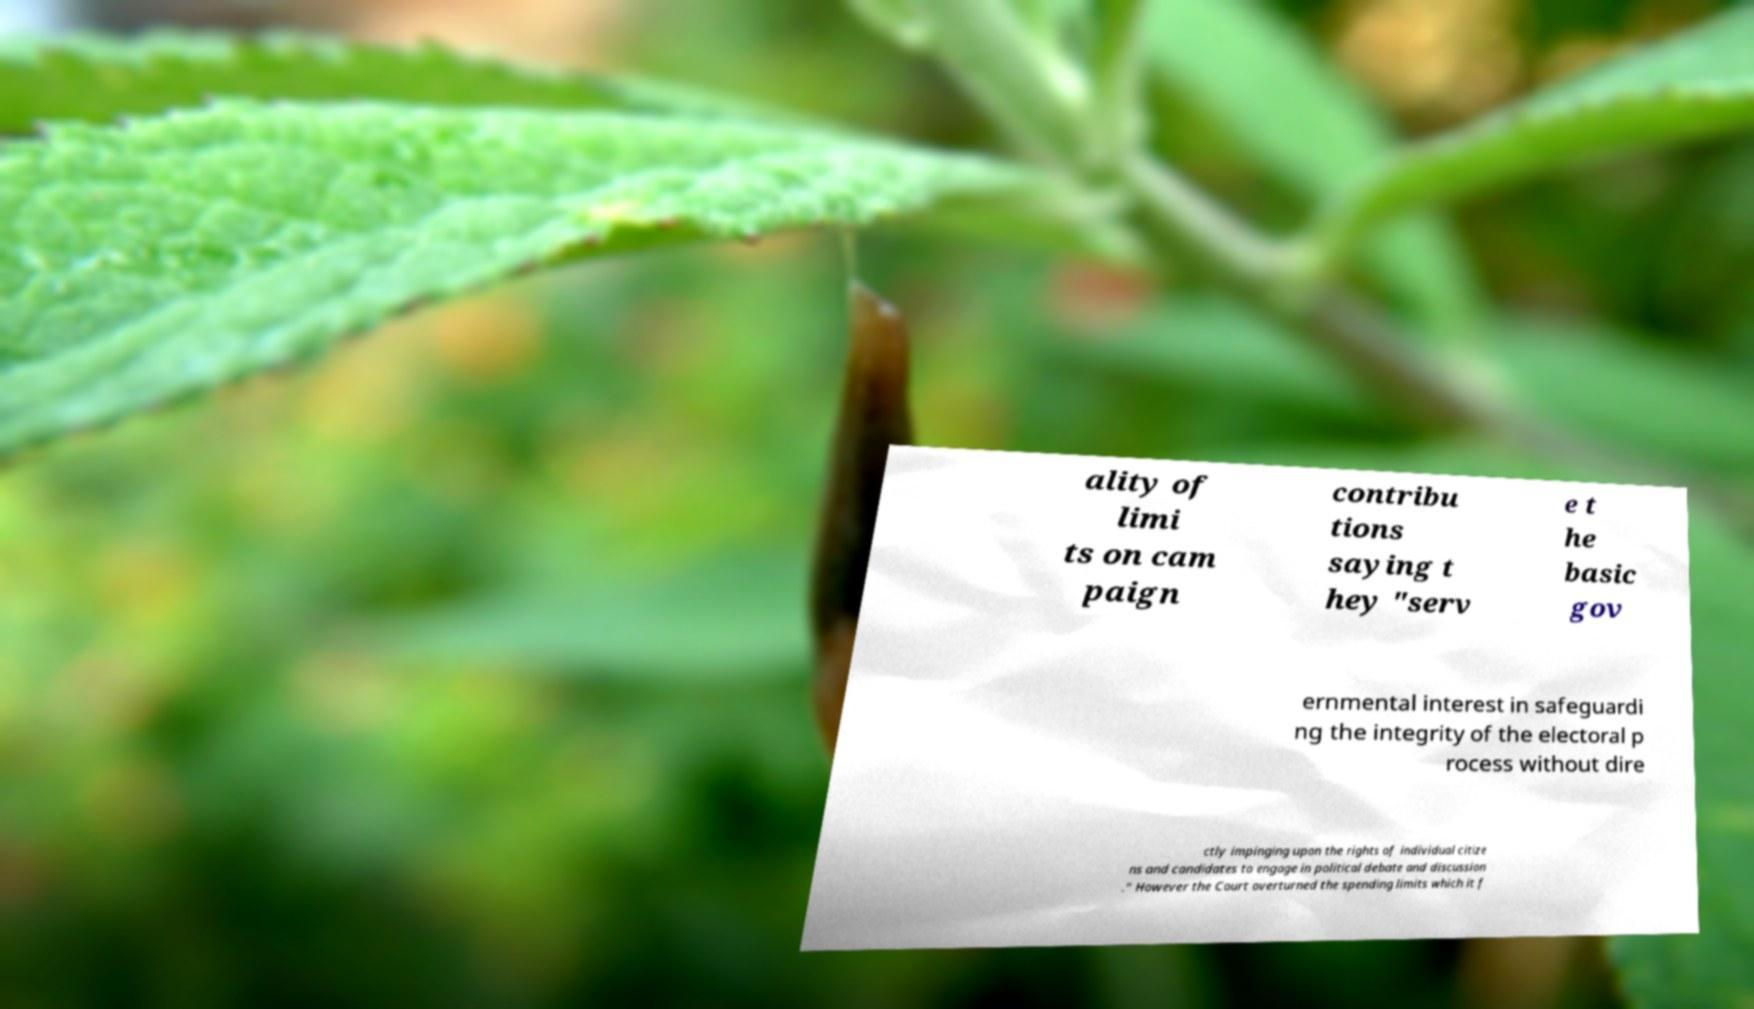What messages or text are displayed in this image? I need them in a readable, typed format. ality of limi ts on cam paign contribu tions saying t hey "serv e t he basic gov ernmental interest in safeguardi ng the integrity of the electoral p rocess without dire ctly impinging upon the rights of individual citize ns and candidates to engage in political debate and discussion ." However the Court overturned the spending limits which it f 